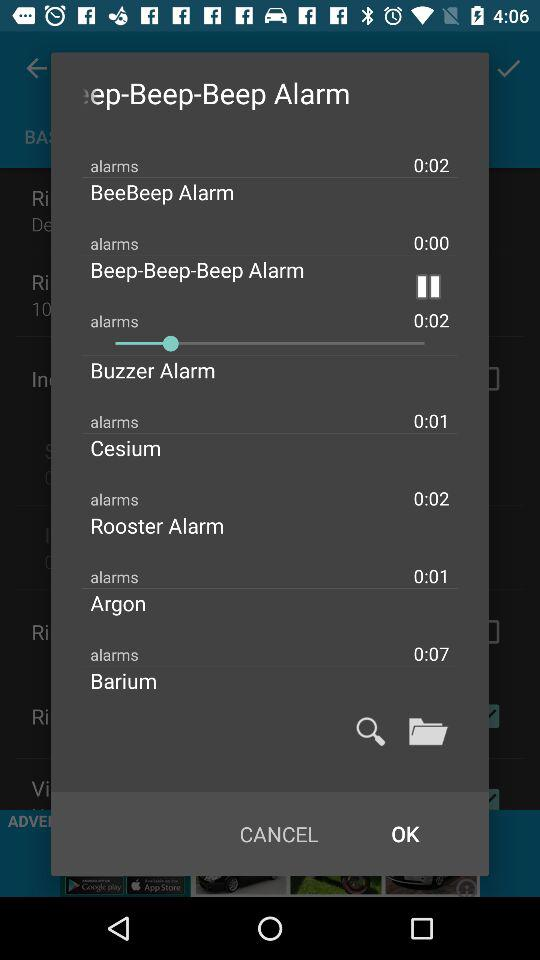What alarm is playing? The alarm playing is "Buzzer Alarm". 